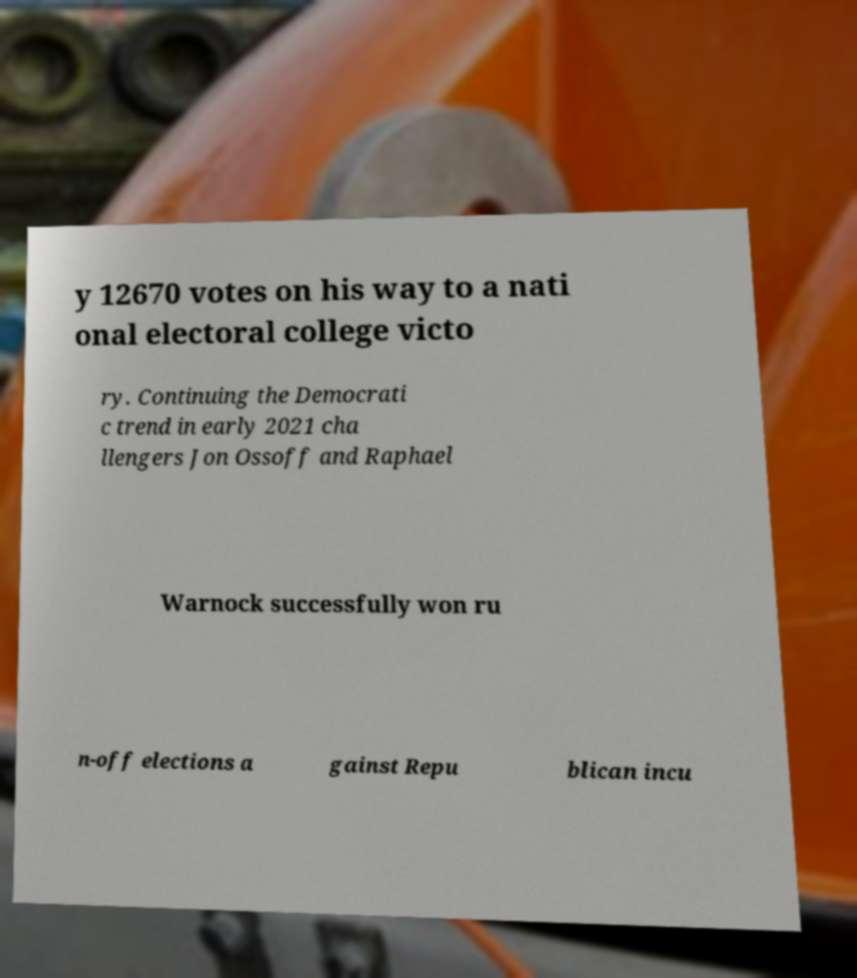What messages or text are displayed in this image? I need them in a readable, typed format. y 12670 votes on his way to a nati onal electoral college victo ry. Continuing the Democrati c trend in early 2021 cha llengers Jon Ossoff and Raphael Warnock successfully won ru n-off elections a gainst Repu blican incu 